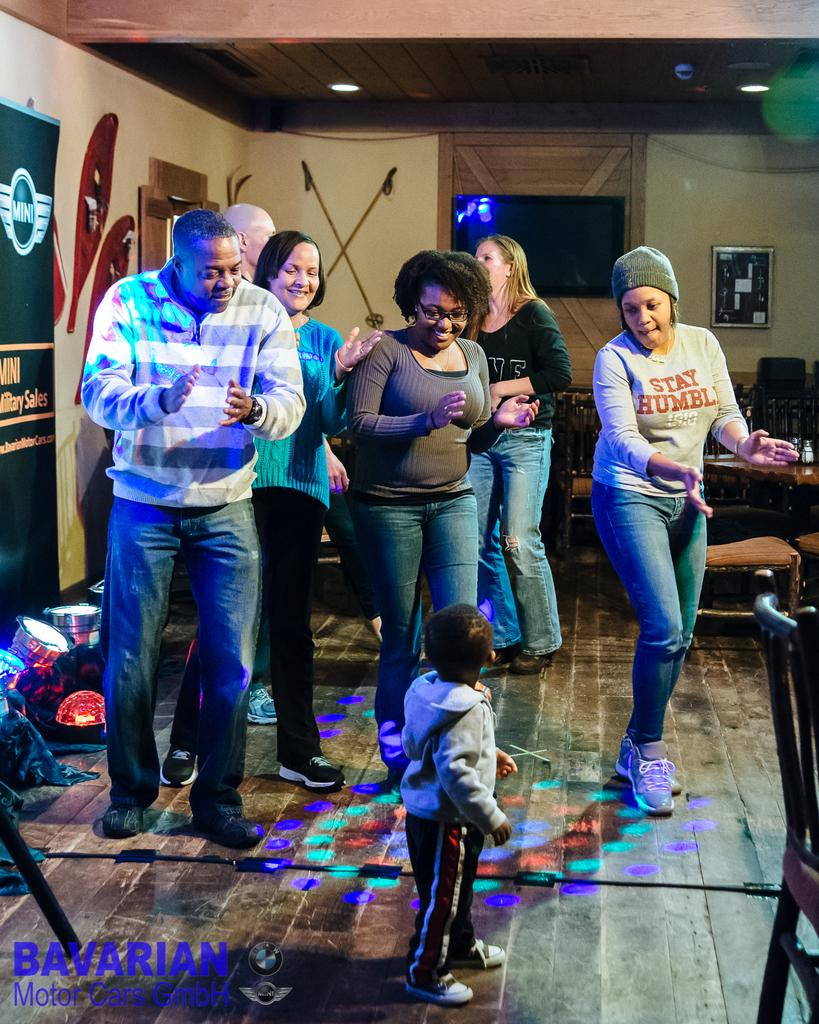Who or what can be seen in the image? There are people in the image. What object is present in the image that might be used for displaying information or messages? There is a board in the image. Where is the television located in the image? The television is on the wall in the image. What object is present in the image that might be used for displaying a picture or decoration? There is a frame in the image. What piece of furniture is present in the image that might be used for placing objects or eating? There is a table in the image. What type of seating is present in the image? There are chairs in the image. What objects in the image might provide illumination? There are lights in the image. What type of pot is visible on the table in the image? There is no pot present on the table in the image. How many rings can be seen on the fingers of the people in the image? There is no information about rings on the fingers of the people in the image. 